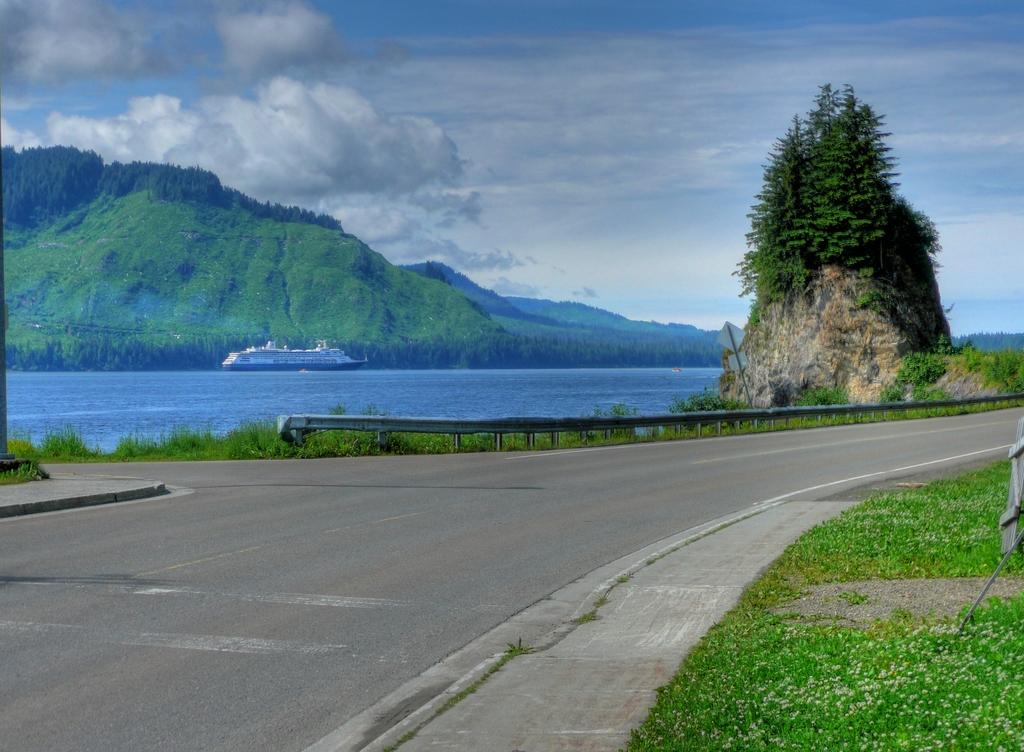What type of surface can be seen in the image? There is a road in the image. What type of vegetation is present in the image? There is grass in the image. What type of barrier can be seen in the image? There is a fence in the image. What type of natural feature is present in the image? There are trees in the image. What type of large landform is present in the image? There are mountains in the image. What type of watercraft can be seen in the image? There is a ship on water in the image. What part of the natural environment is visible in the background of the image? The sky is visible in the background of the image. What type of atmospheric feature can be seen in the sky? Clouds are present in the sky. How many jellyfish are swimming in the water near the ship in the image? There are no jellyfish present in the image; it features a ship on water. What type of produce is growing on the trees in the image? There is no produce growing on the trees in the image; the trees are not specified as fruit-bearing trees. 